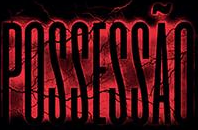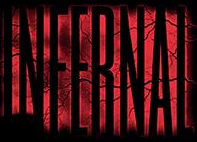Identify the words shown in these images in order, separated by a semicolon. POSSESSÃO; INFERNAL 